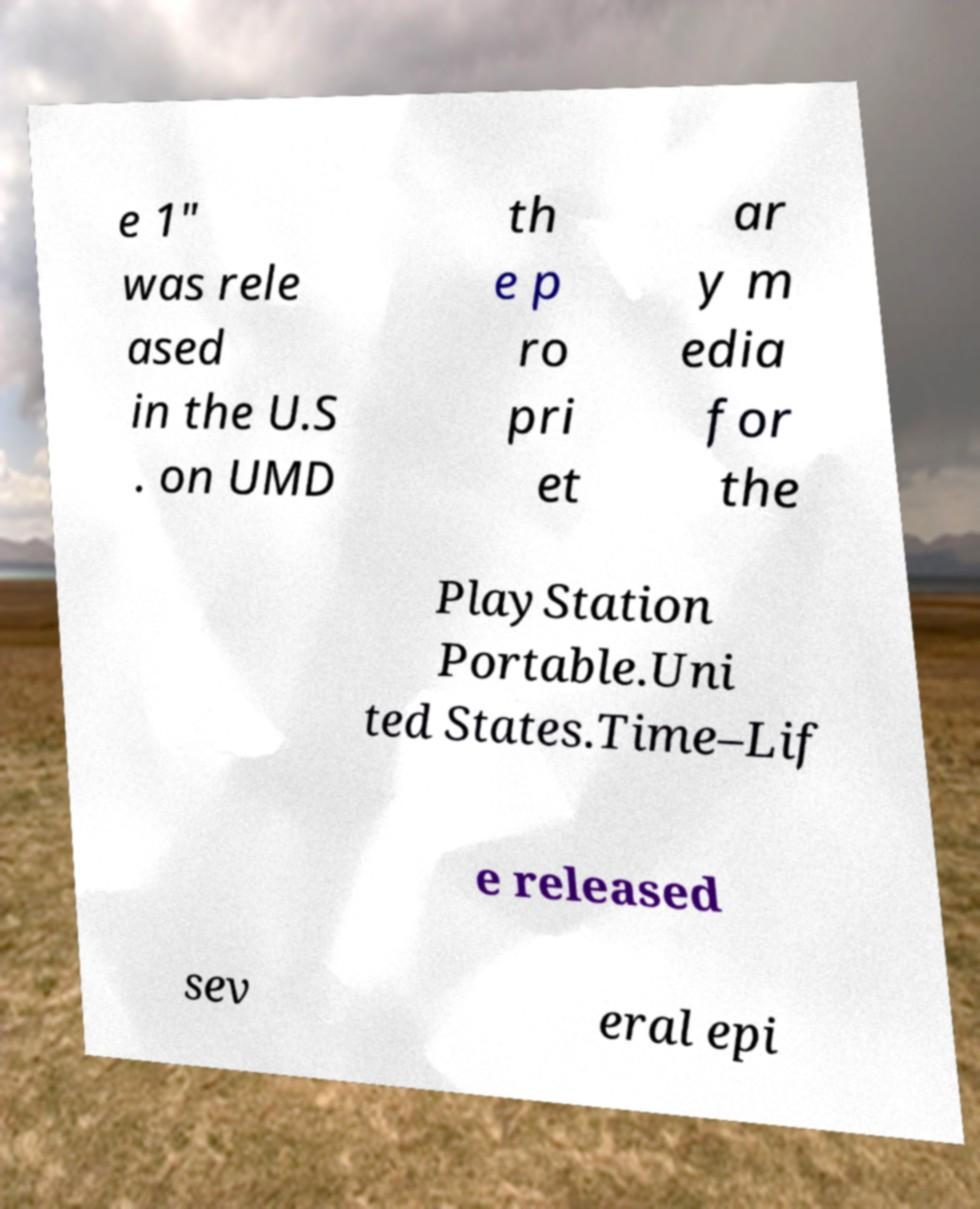Can you accurately transcribe the text from the provided image for me? e 1" was rele ased in the U.S . on UMD th e p ro pri et ar y m edia for the PlayStation Portable.Uni ted States.Time–Lif e released sev eral epi 